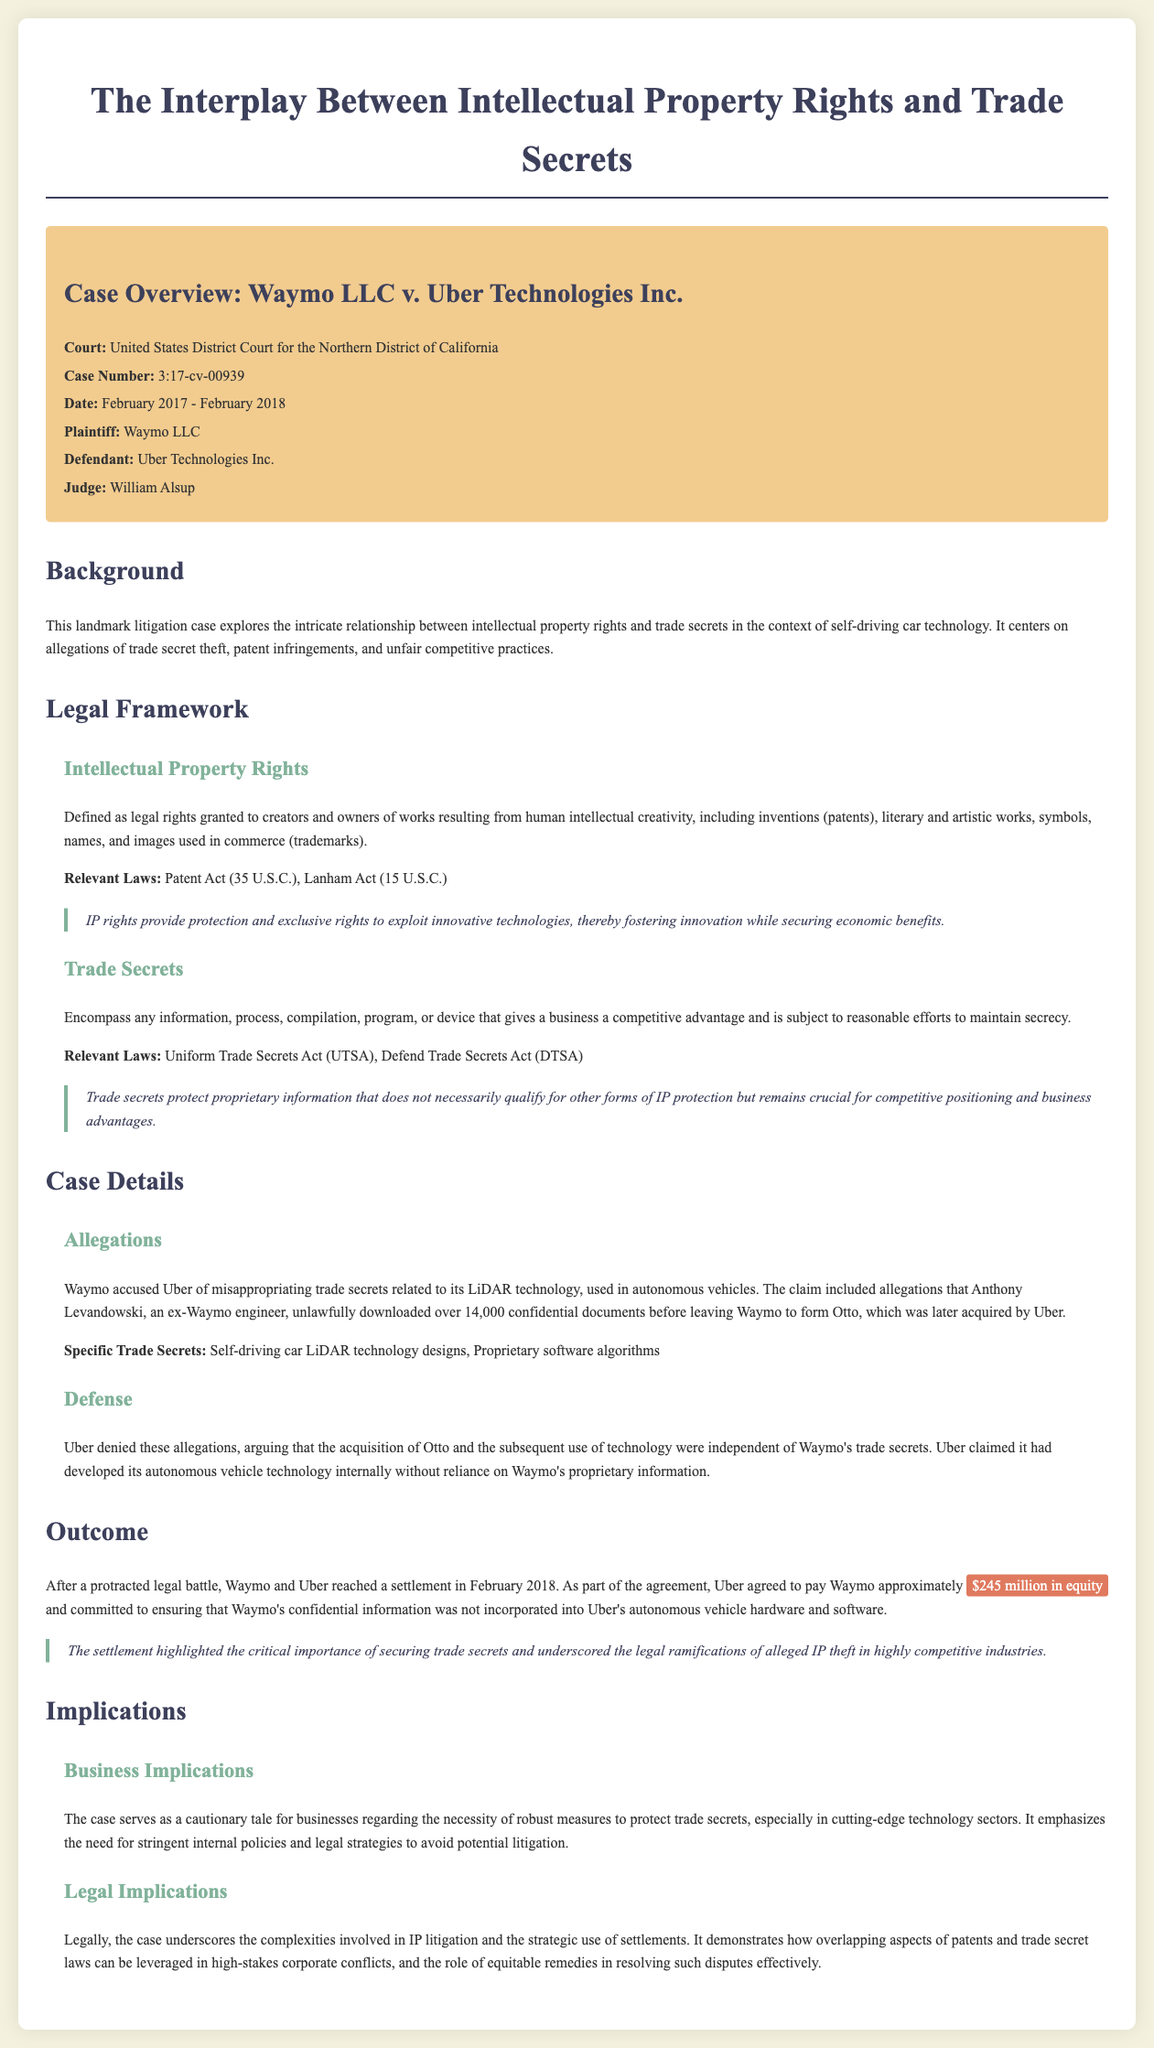What is the court for the case? The court information is provided in the case overview section, which identifies the specific court dealing with the case.
Answer: United States District Court for the Northern District of California Who is the plaintiff in this case? This information is found in the case overview and specifies the party bringing the lawsuit.
Answer: Waymo LLC What date range did the case cover? The date range is mentioned in the case overview, indicating when the litigation took place.
Answer: February 2017 - February 2018 What was the settlement amount agreed upon? The outcome section details the terms of the settlement, including financial compensation.
Answer: $245 million in equity What technology was involved in the trade secret allegations? The details regarding specific allegations are provided in the case details section, focusing on the technology in question.
Answer: LiDAR technology What defense did Uber provide against the allegations? The defense strategy outlined in the document indicates Uber's approach to counter the accusations.
Answer: Developed technology internally How did the outcome of the case emphasize trade secret protection? The implications section discusses the broader message from the case about protecting confidential information.
Answer: Securing trade secrets What legal framework governs the trade secrets mentioned? The legal framework section specifies the relevant laws associated with trade secrets.
Answer: Uniform Trade Secrets Act (UTSA), Defend Trade Secrets Act (DTSA) What role did the judge play in this case? The document provides the name of the judge overseeing the case, indicating the judicial authority involved.
Answer: William Alsup 